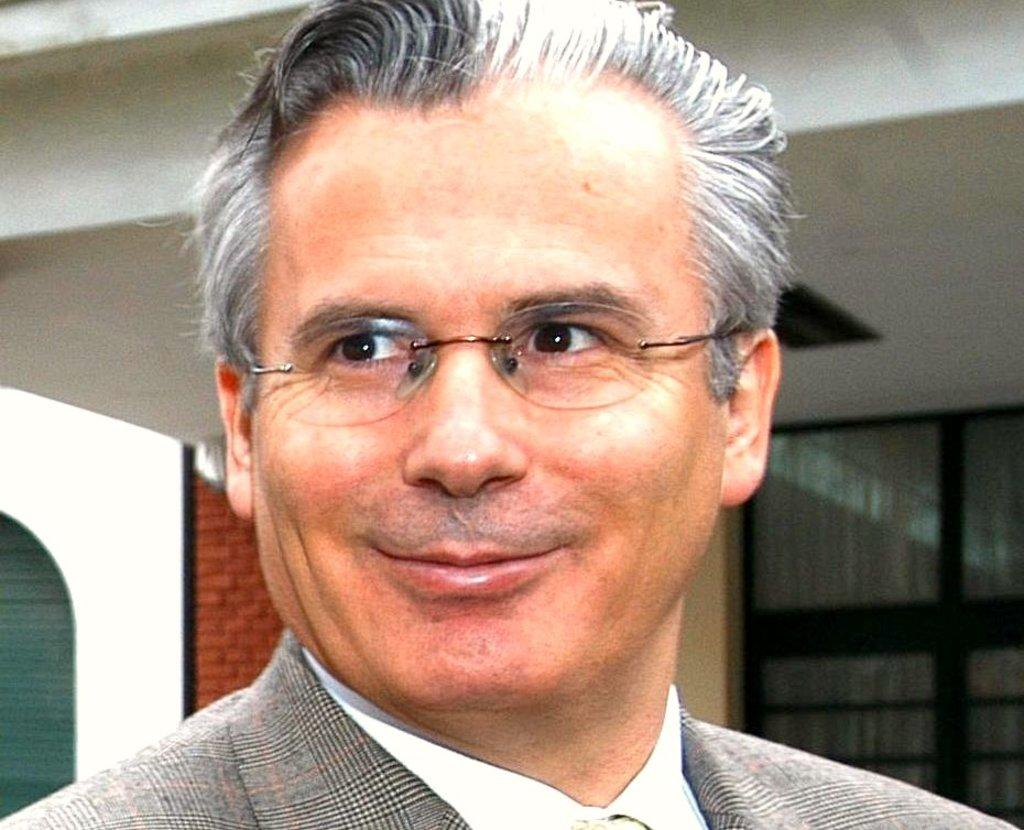What is present in the image? There is a person in the image. How is the person's expression? The person has a smiling face. What can be seen through the window in the image? The image does not show what can be seen through the window. What is visible on the wall in the image? The image does not show any specific details on the wall. How much money is the cow standing on the land in the image? There is no cow or land present in the image; it only features a person with a smiling face. 